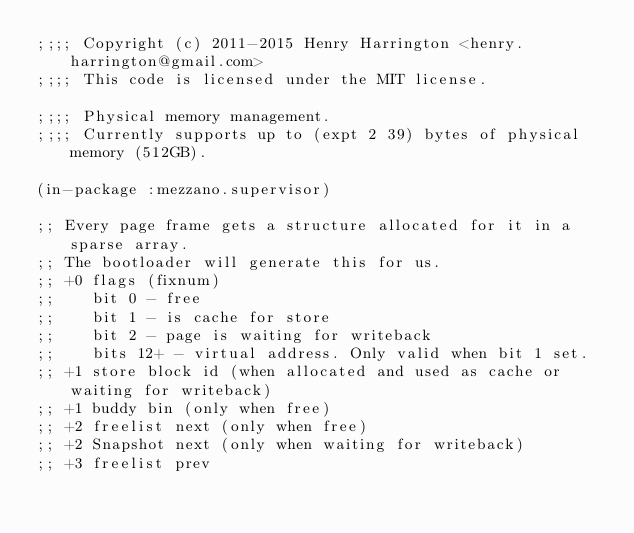Convert code to text. <code><loc_0><loc_0><loc_500><loc_500><_Lisp_>;;;; Copyright (c) 2011-2015 Henry Harrington <henry.harrington@gmail.com>
;;;; This code is licensed under the MIT license.

;;;; Physical memory management.
;;;; Currently supports up to (expt 2 39) bytes of physical memory (512GB).

(in-package :mezzano.supervisor)

;; Every page frame gets a structure allocated for it in a sparse array.
;; The bootloader will generate this for us.
;; +0 flags (fixnum)
;;    bit 0 - free
;;    bit 1 - is cache for store
;;    bit 2 - page is waiting for writeback
;;    bits 12+ - virtual address. Only valid when bit 1 set.
;; +1 store block id (when allocated and used as cache or waiting for writeback)
;; +1 buddy bin (only when free)
;; +2 freelist next (only when free)
;; +2 Snapshot next (only when waiting for writeback)
;; +3 freelist prev</code> 